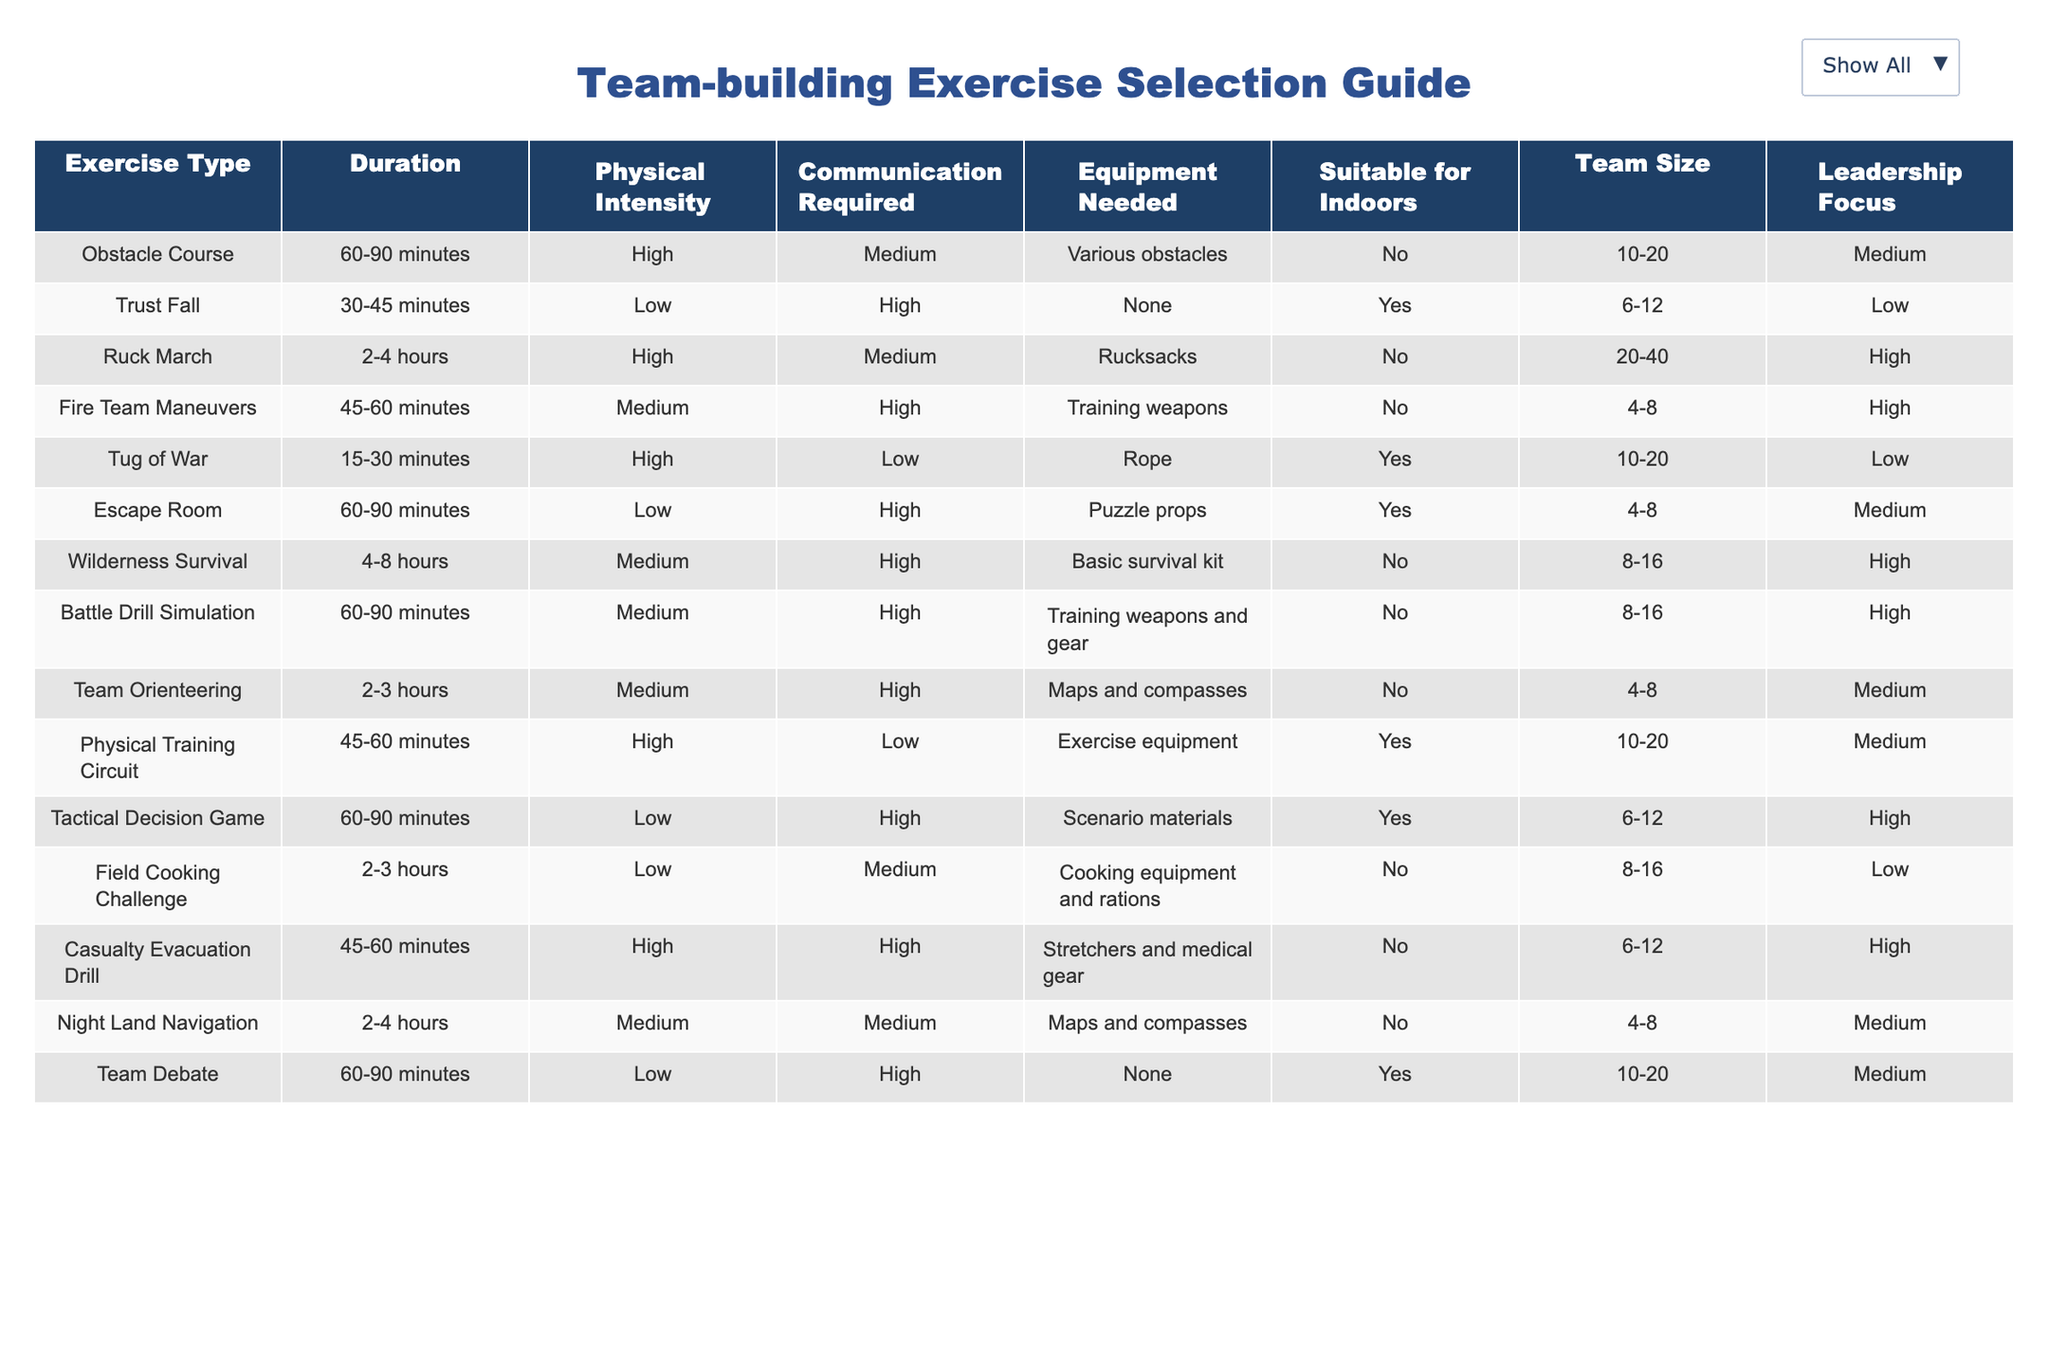What is the physical intensity of the Trust Fall exercise? The physical intensity of the Trust Fall exercise is listed in the table as 'Low'.
Answer: Low How many exercises require a team size of 8-16? To find the number of exercises with a team size of 8-16, we can filter the table for the 'Team Size' column. The exercises in this range are Wilderness Survival, Battle Drill Simulation, and Field Cooking Challenge. This gives us a total of 3 exercises.
Answer: 3 Is the Ruck March suitable for indoors? The table states that the Ruck March is not suitable for indoors, as indicated by 'No' in the corresponding column.
Answer: No What exercise has the highest leadership focus among those suitable for indoors? The suitable exercises for indoors are Trust Fall, Tug of War, Escape Room, Physical Training Circuit, Tactical Decision Game, Team Debate. Among these, the Physical Training Circuit and Team Debate have a leadership focus marked as 'Medium', while the others have 'Low'. So, the highest leadership focus is Medium.
Answer: Medium What is the average duration of all exercises? To find the average duration, we first need to convert the durations into a numeric value. We categorize them as follows: Obstacle Course (75), Trust Fall (37.5), Ruck March (180), Fire Team Maneuvers (52.5), Tug of War (22.5), Escape Room (75), Wilderness Survival (360), Battle Drill Simulation (75), Team Orienteering (150), Physical Training Circuit (52.5), Tactical Decision Game (75), Field Cooking Challenge (150), Casualty Evacuation Drill (52.5), Night Land Navigation (180), Team Debate (75). Summing these values gives 1115. Now, we divide by the number of exercises, which is 14. Thus, the average is 1115/14 = 79.64 minutes.
Answer: 79.64 Which exercise requires communication but has low physical intensity? Only two exercises in the table are marked as having low physical intensity. They are the Trust Fall and the Escape Room. Among these, the Escape Room requires high communication as indicated in the table. The Trust Fall requires high communication. Thus, both exercises fit the criteria.
Answer: Trust Fall, Escape Room 